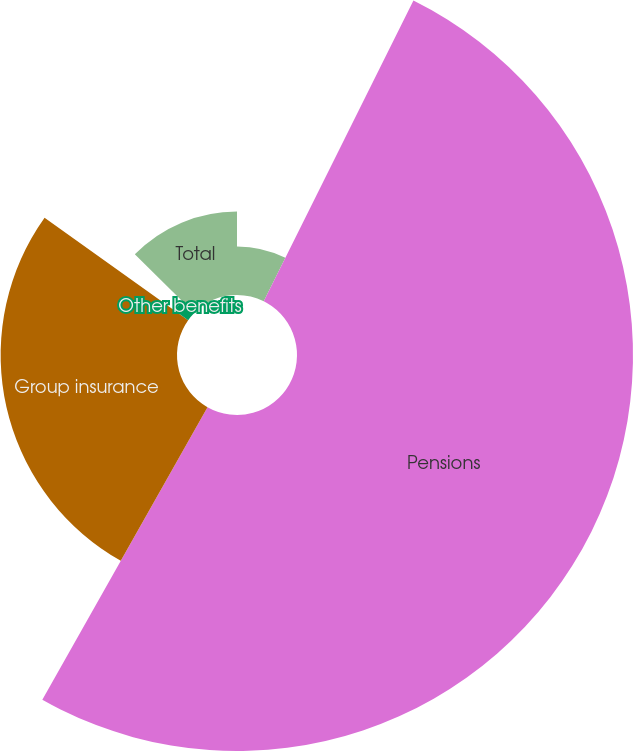<chart> <loc_0><loc_0><loc_500><loc_500><pie_chart><fcel>Salaries and wages<fcel>Pensions<fcel>Group insurance<fcel>Other benefits<fcel>Total<nl><fcel>7.35%<fcel>50.83%<fcel>26.68%<fcel>2.52%<fcel>12.62%<nl></chart> 